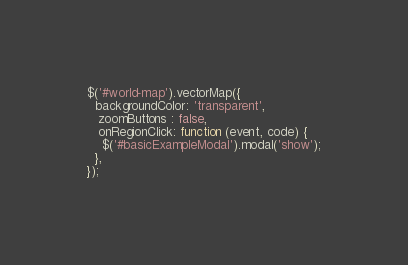Convert code to text. <code><loc_0><loc_0><loc_500><loc_500><_JavaScript_>$('#world-map').vectorMap({
  backgroundColor: 'transparent',
   zoomButtons : false,
   onRegionClick: function (event, code) {
    $('#basicExampleModal').modal('show');
  },
});
</code> 